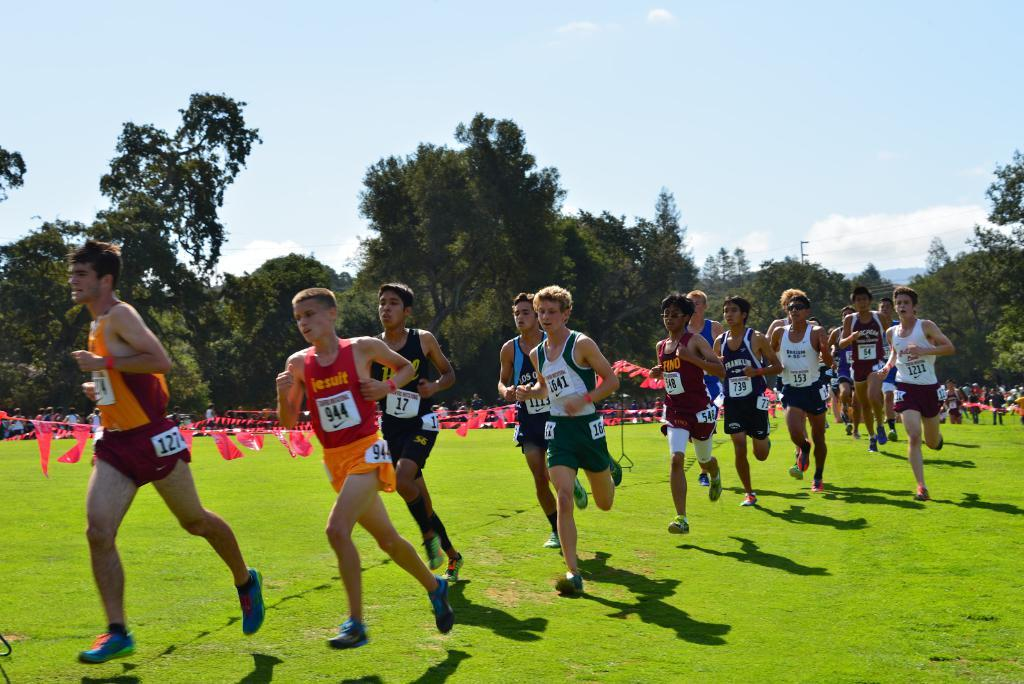What are the people in the image doing? People are running in the image. What type of terrain can be seen in the image? The grass is visible in the image. What objects are present in the image that are not related to the people running? There are red flags in the image. What can be seen in the background of the image? There are trees in the background of the image. What type of straw is being used to power the apparatus in the image? There is no apparatus or straw present in the image; it features people running and red flags. 